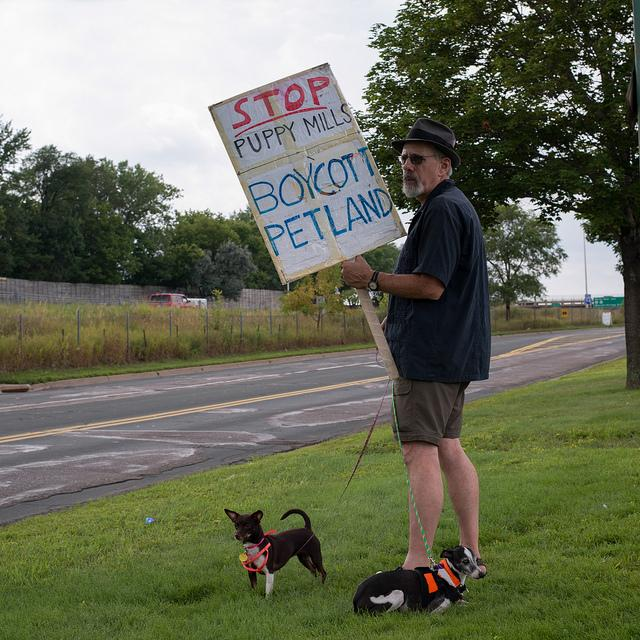What sort of life does this man advocate for? animals 